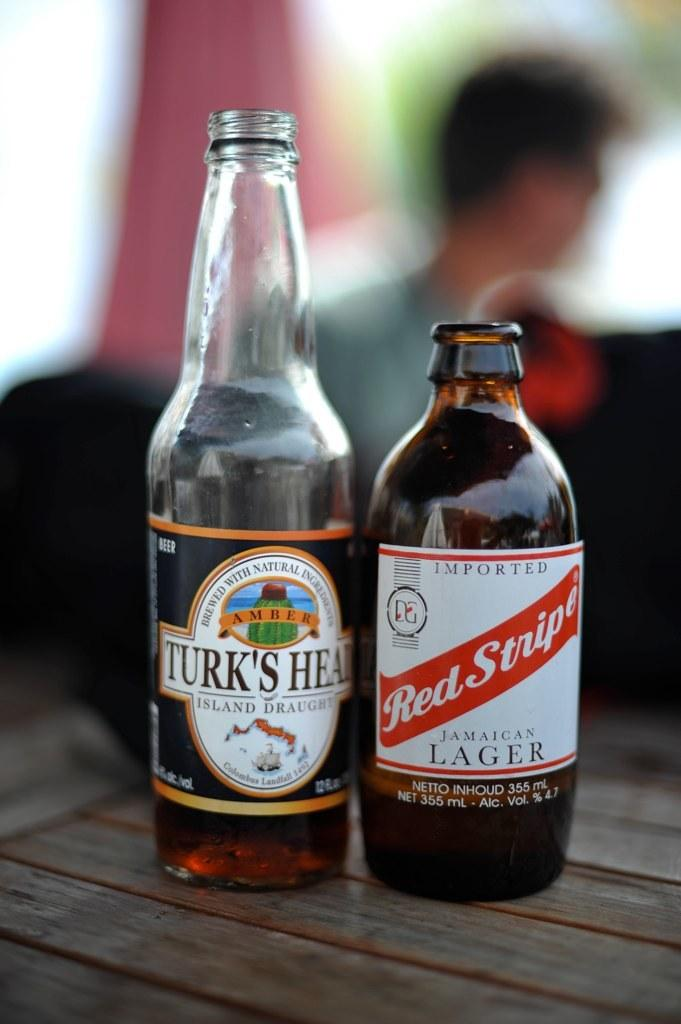<image>
Share a concise interpretation of the image provided. Two bottles labeled Turk's Head and Red Stripe on a table. 